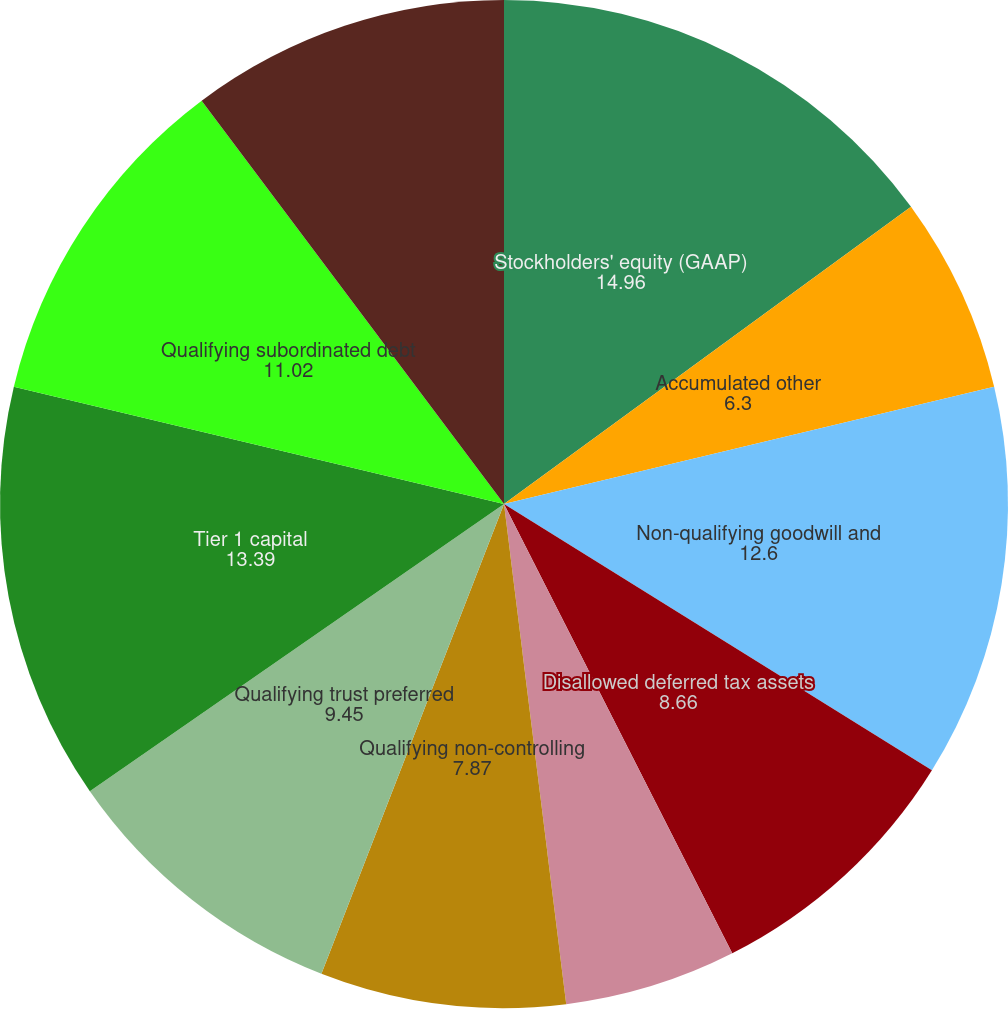Convert chart. <chart><loc_0><loc_0><loc_500><loc_500><pie_chart><fcel>Stockholders' equity (GAAP)<fcel>Accumulated other<fcel>Non-qualifying goodwill and<fcel>Disallowed deferred tax assets<fcel>Disallowed servicing assets<fcel>Qualifying non-controlling<fcel>Qualifying trust preferred<fcel>Tier 1 capital<fcel>Qualifying subordinated debt<fcel>Adjusted allowance for loan<nl><fcel>14.96%<fcel>6.3%<fcel>12.6%<fcel>8.66%<fcel>5.51%<fcel>7.87%<fcel>9.45%<fcel>13.39%<fcel>11.02%<fcel>10.24%<nl></chart> 